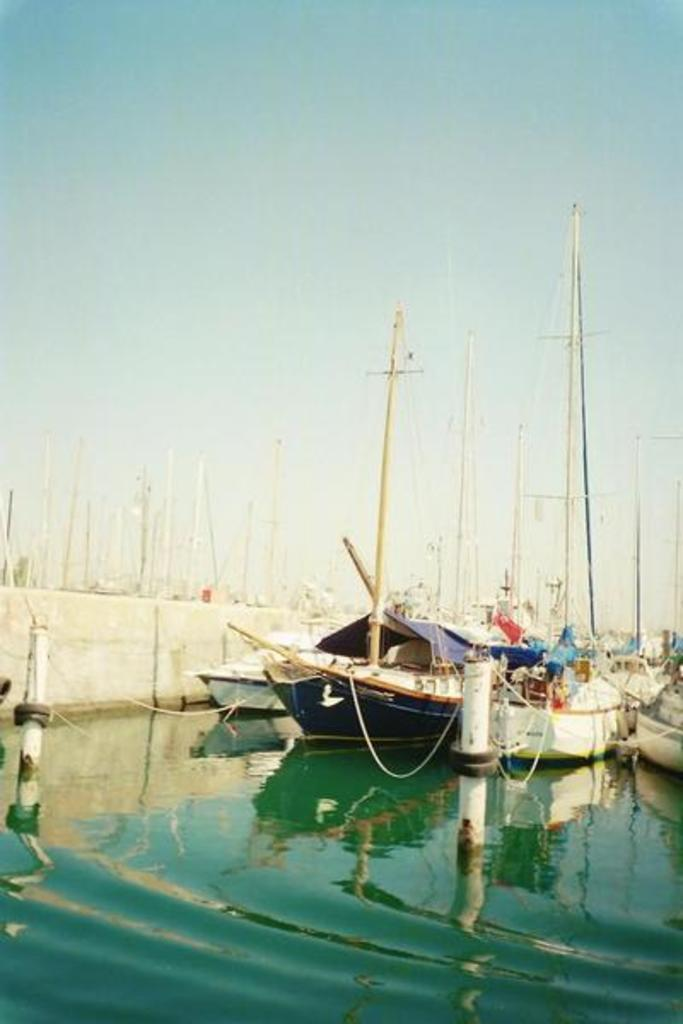What is on the water in the image? There is a fleet on the water in the image. What can be seen in the background of the image? The sky is visible in the background of the image. What structures are present in the image? There is a wall and poles in the image. What is the primary element visible in the image? Water is visible in the image. How many fingers can be seen in the image? There are no fingers visible in the image. Are there any jellyfish in the water in the image? There is no mention of jellyfish in the image; it features a fleet on the water. 